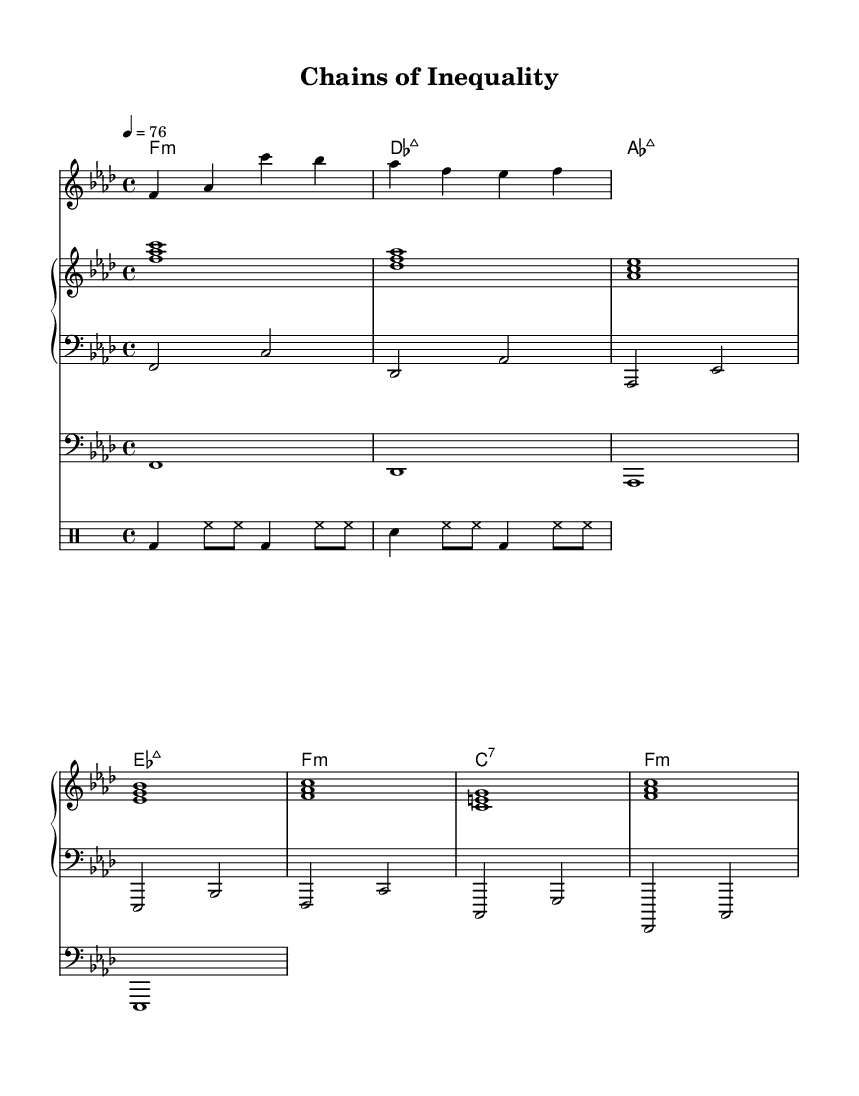What is the key signature of this music? The key signature is F minor, which is indicated by four flats.
Answer: F minor What is the time signature of the song? The time signature is 4/4, as shown at the beginning of the score.
Answer: 4/4 What is the tempo marking given in the music? The tempo marking states "4 = 76," indicating the quarter note beats per minute.
Answer: 76 How many bars are present in the chorus? The chorus has four measures as indicated by the four lines of lyrics that correspond to musical phrases.
Answer: Four What is the primary theme of the lyrics in this piece? The primary theme focuses on systemic inequality and fighting for justice, as evident in the lyrics that discuss societal issues.
Answer: Systemic inequality In which section are the drum patterns written? The drum patterns are written in the "DrumStaff" section of the score.
Answer: DrumStaff What type of chord progression is used in the verse? The chord progression in the verse utilizes minor and major chords, reflecting common techniques in R&B music structures.
Answer: Minor and major chords 